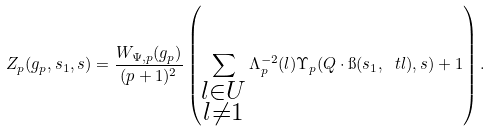Convert formula to latex. <formula><loc_0><loc_0><loc_500><loc_500>Z _ { p } ( g _ { p } , s _ { 1 } , s ) = \frac { W _ { \Psi , p } ( g _ { p } ) } { ( p + 1 ) ^ { 2 } } \left ( \sum _ { \substack { l \in U \\ l \ne 1 } } \Lambda _ { p } ^ { - 2 } ( l ) \Upsilon _ { p } ( Q \cdot \i ( s _ { 1 } , \ t l ) , s ) + 1 \right ) .</formula> 